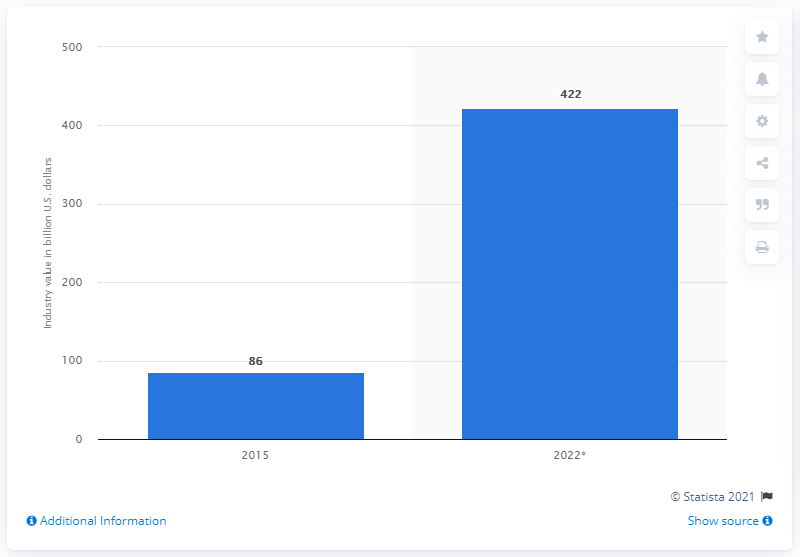List a handful of essential elements in this visual. The global solar energy market in 2015 was estimated to be approximately 86... The global solar energy market is expected to reach 422 by 2022. 